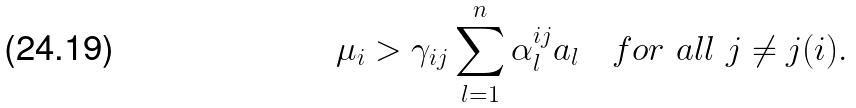<formula> <loc_0><loc_0><loc_500><loc_500>\mu _ { i } > \gamma _ { i j } \sum _ { l = 1 } ^ { n } \alpha _ { l } ^ { i j } a _ { l } \quad f o r \ a l l \ j \ne j ( i ) .</formula> 